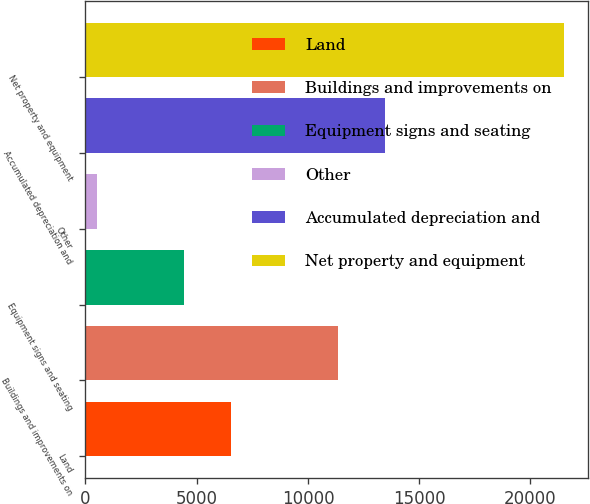Convert chart to OTSL. <chart><loc_0><loc_0><loc_500><loc_500><bar_chart><fcel>Land<fcel>Buildings and improvements on<fcel>Equipment signs and seating<fcel>Other<fcel>Accumulated depreciation and<fcel>Net property and equipment<nl><fcel>6525.81<fcel>11347.9<fcel>4422.9<fcel>502.4<fcel>13450.8<fcel>21531.5<nl></chart> 